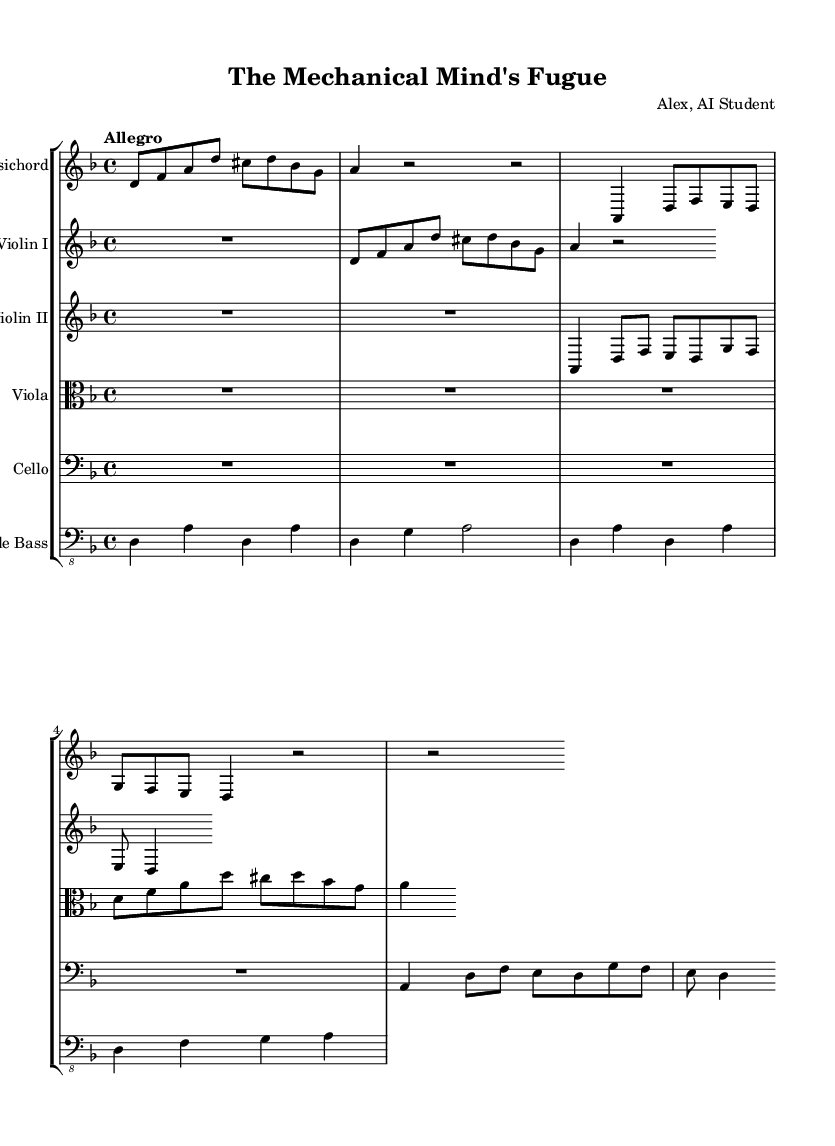What is the key signature of this music? The key signature indicated at the beginning of the score is D minor, which has one flat (B flat). This is often represented by the clef symbol followed by the key signature on the staff.
Answer: D minor What is the time signature of the piece? The time signature shown at the start of the sheet music is 4/4, which means there are four beats in each measure and the quarter note gets one beat. This is typically noted right after the key signature.
Answer: 4/4 What is the tempo indication for this concerto? The tempo marking "Allegro" indicates that the piece should be played at a lively and brisk pace. This word is often included at the beginning of a score to give performers guidance on the speed of the music.
Answer: Allegro How many measures are visible in the harpsichord part? Looking closely at the harpsichord part provided in the score, we can count 4 visible measures that include defined musical content. Although there are indications for more measures, they are not fully written out in the provided excerpt.
Answer: 4 Which instrument plays the main theme first? The harpsichord section plays the main theme first, as it is the first part presented in the score after the global settings. This is highlighted because the main theme is denoted above the clefs in the individual instrument parts.
Answer: Harpsichord In what style is the composition presented? The composition is presented in a Baroque style, characterized by its use of ornamentation, counterpoint, and the harpsichord as a primary instrument. This can be deduced from the historical context and the characteristics of the musical form presented in the score.
Answer: Baroque 